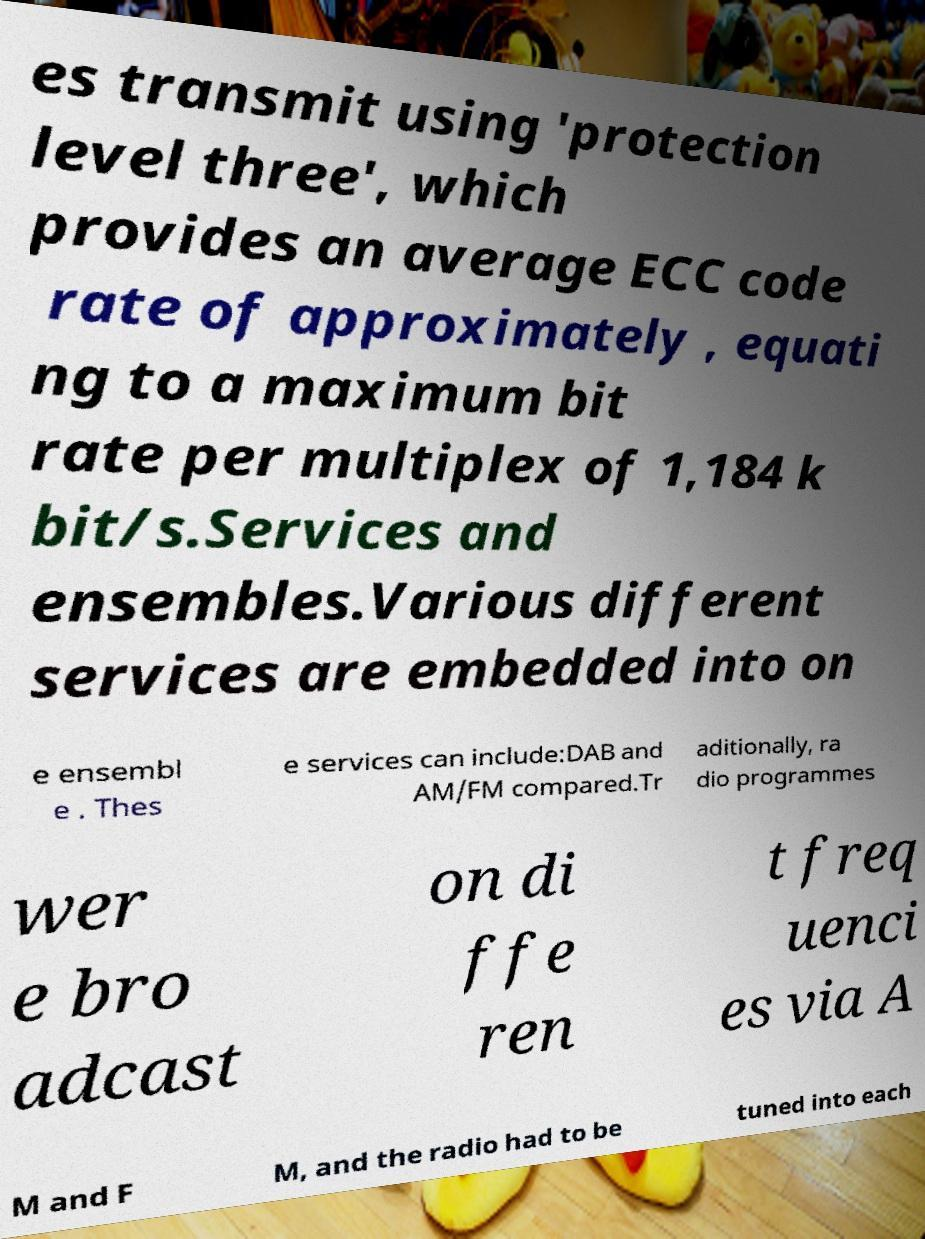Can you read and provide the text displayed in the image?This photo seems to have some interesting text. Can you extract and type it out for me? es transmit using 'protection level three', which provides an average ECC code rate of approximately , equati ng to a maximum bit rate per multiplex of 1,184 k bit/s.Services and ensembles.Various different services are embedded into on e ensembl e . Thes e services can include:DAB and AM/FM compared.Tr aditionally, ra dio programmes wer e bro adcast on di ffe ren t freq uenci es via A M and F M, and the radio had to be tuned into each 